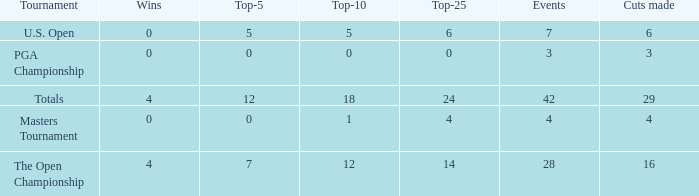What are the lowest top-5 with a top-25 larger than 4, 29 cuts and a top-10 larger than 18? None. 